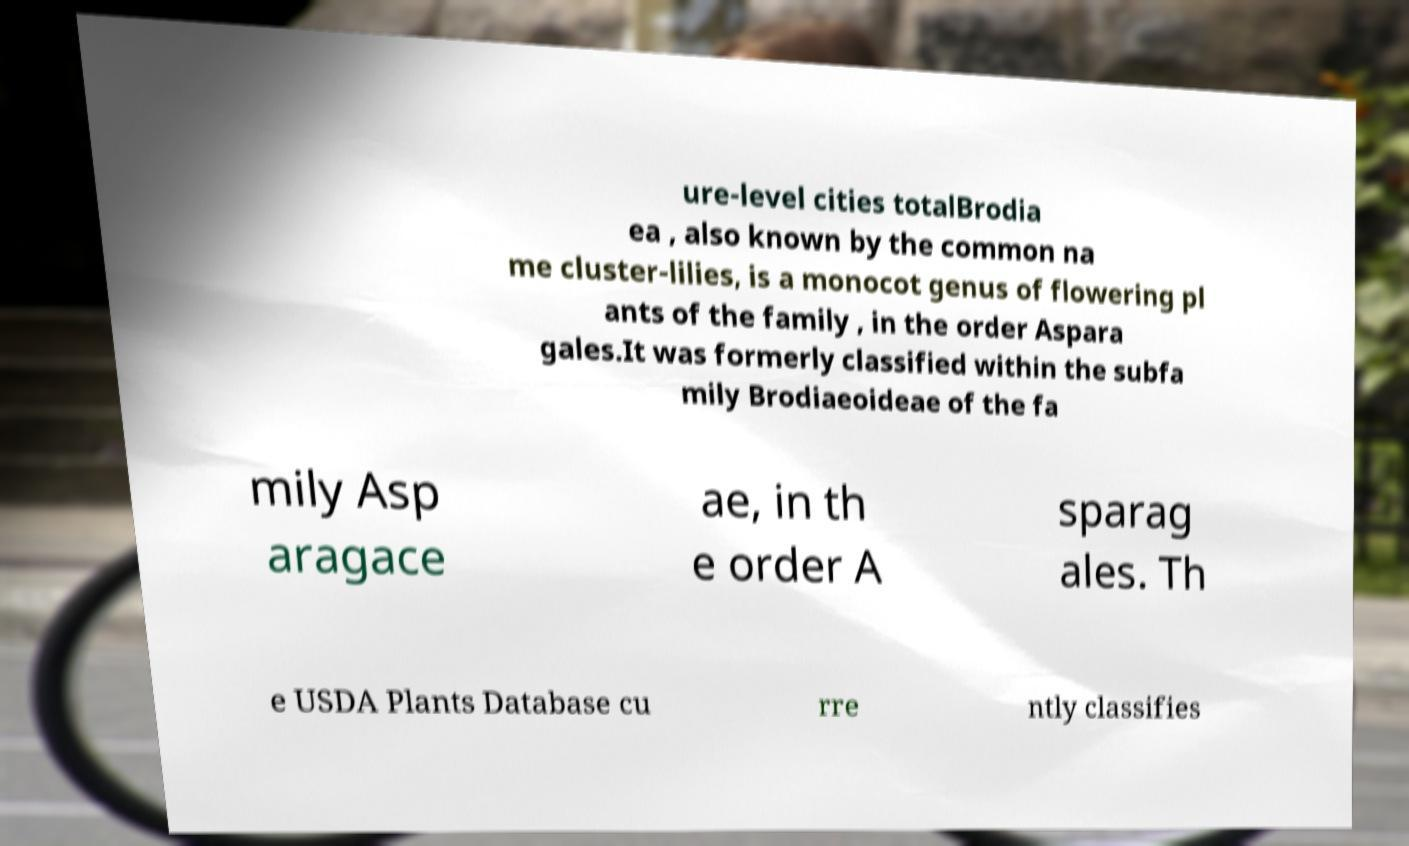There's text embedded in this image that I need extracted. Can you transcribe it verbatim? ure-level cities totalBrodia ea , also known by the common na me cluster-lilies, is a monocot genus of flowering pl ants of the family , in the order Aspara gales.It was formerly classified within the subfa mily Brodiaeoideae of the fa mily Asp aragace ae, in th e order A sparag ales. Th e USDA Plants Database cu rre ntly classifies 